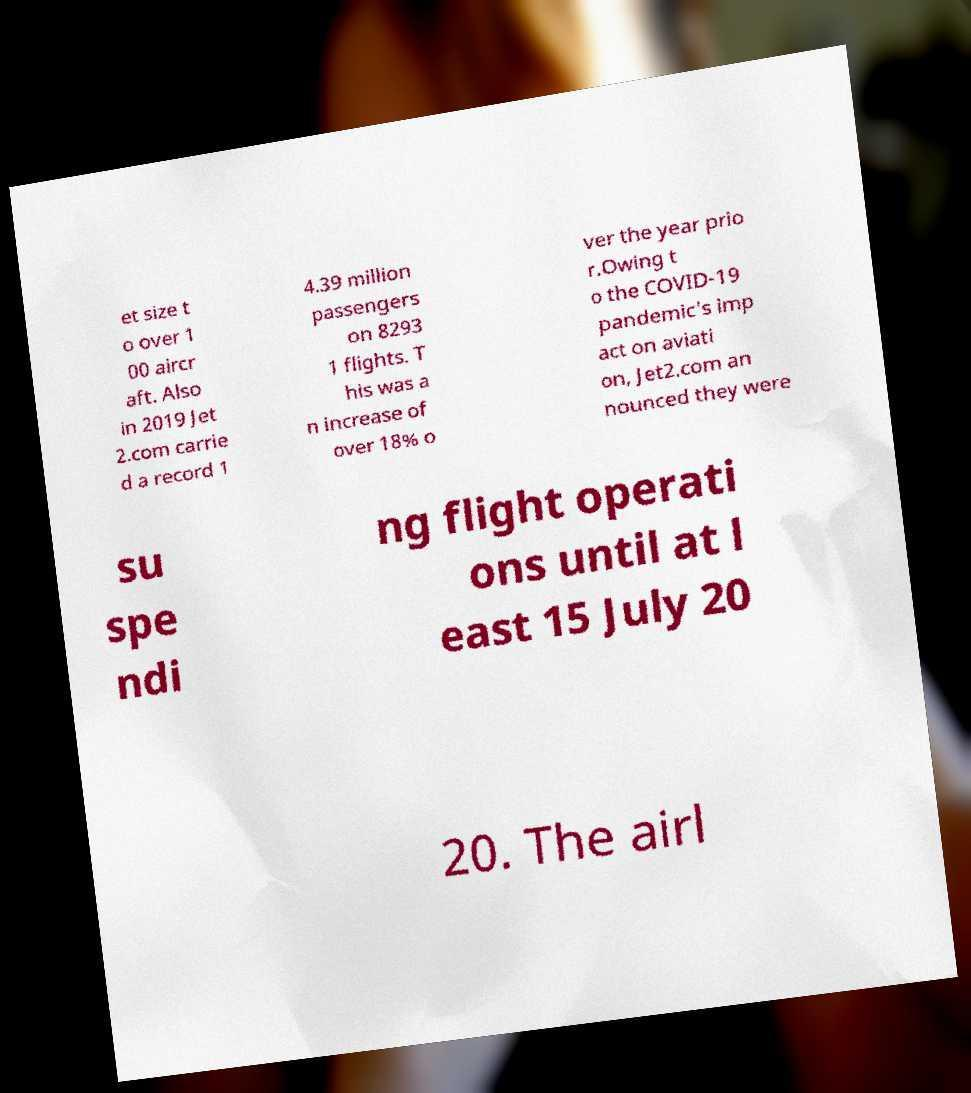Please identify and transcribe the text found in this image. et size t o over 1 00 aircr aft. Also in 2019 Jet 2.com carrie d a record 1 4.39 million passengers on 8293 1 flights. T his was a n increase of over 18% o ver the year prio r.Owing t o the COVID-19 pandemic's imp act on aviati on, Jet2.com an nounced they were su spe ndi ng flight operati ons until at l east 15 July 20 20. The airl 